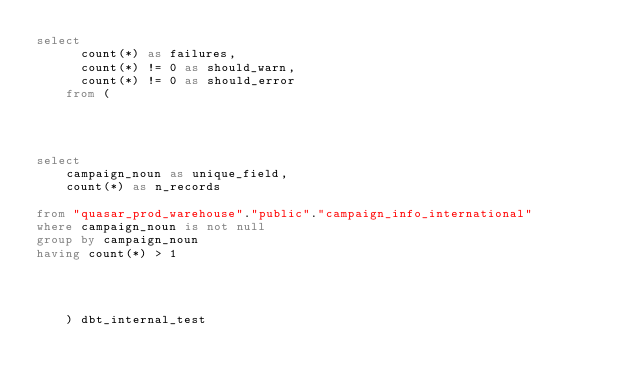Convert code to text. <code><loc_0><loc_0><loc_500><loc_500><_SQL_>select
      count(*) as failures,
      count(*) != 0 as should_warn,
      count(*) != 0 as should_error
    from (
      
    
    

select
    campaign_noun as unique_field,
    count(*) as n_records

from "quasar_prod_warehouse"."public"."campaign_info_international"
where campaign_noun is not null
group by campaign_noun
having count(*) > 1



      
    ) dbt_internal_test</code> 